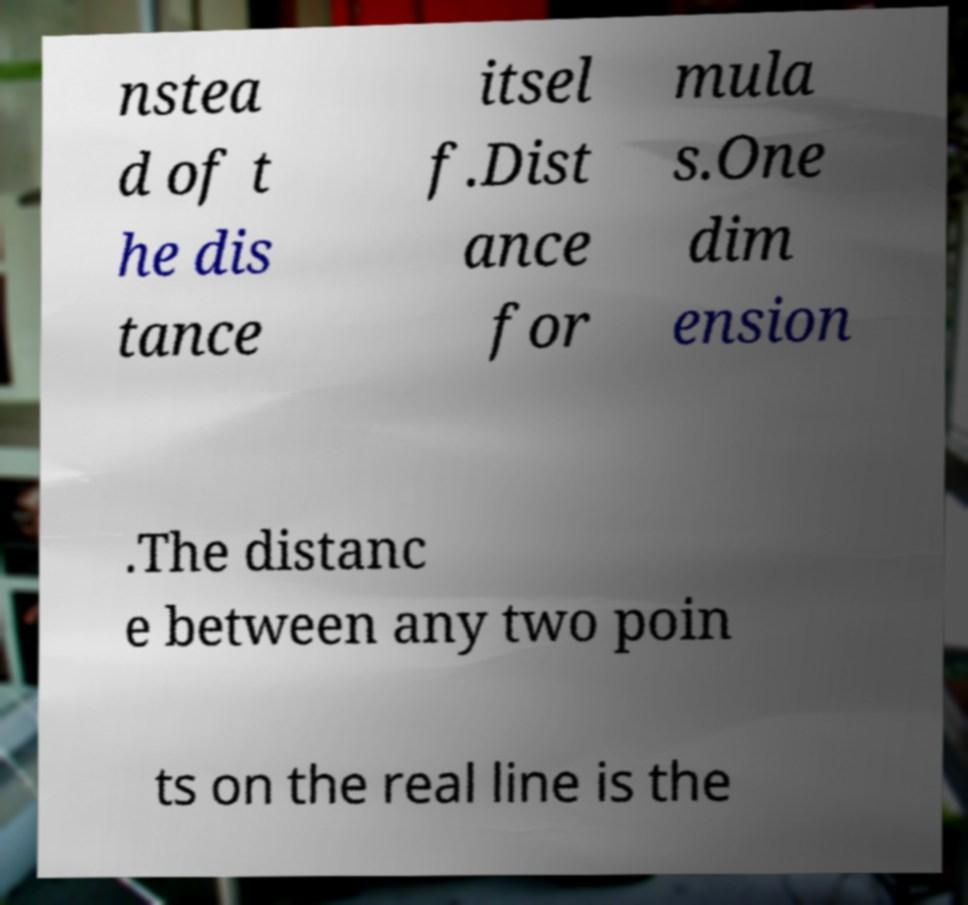There's text embedded in this image that I need extracted. Can you transcribe it verbatim? nstea d of t he dis tance itsel f.Dist ance for mula s.One dim ension .The distanc e between any two poin ts on the real line is the 